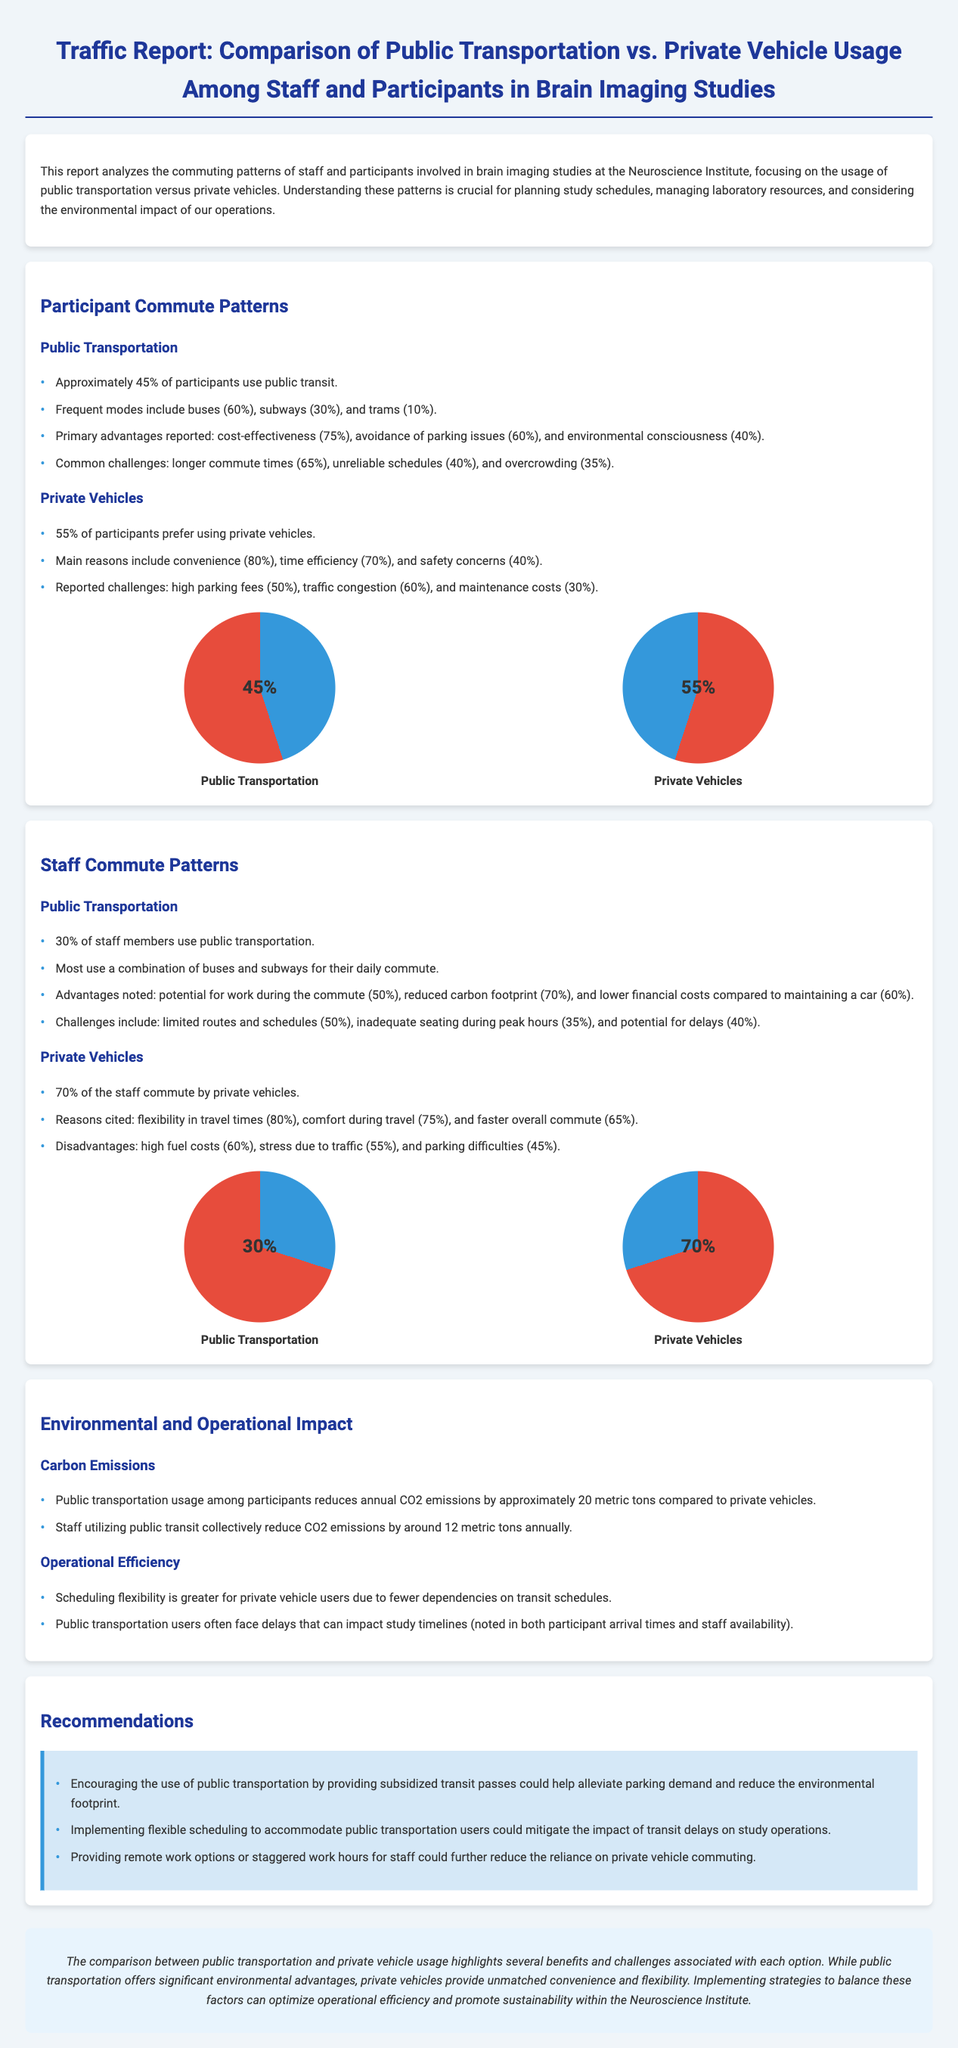what percentage of participants use public transportation? The document states that approximately 45% of participants use public transit.
Answer: 45% what are the main public transportation modes used by participants? The report lists buses (60%), subways (30%), and trams (10%) as the main modes.
Answer: buses, subways, trams what are the primary advantages of public transportation for participants? The advantages reported by participants include cost-effectiveness (75%), avoidance of parking issues (60%), and environmental consciousness (40%).
Answer: cost-effectiveness, avoidance of parking issues, environmental consciousness how much CO2 emissions are reduced annually by staff utilizing public transit? It is stated that staff utilizing public transit reduce CO2 emissions by around 12 metric tons annually.
Answer: 12 metric tons what flexibility benefit do private vehicle users have compared to public transport users? The document mentions that scheduling flexibility is greater for private vehicle users.
Answer: scheduling flexibility which group has a higher preference for private vehicles, participants or staff? The report shows that 70% of staff commute by private vehicles while 55% of participants prefer them.
Answer: staff what is a recommended strategy to encourage public transportation usage? The report recommends providing subsidized transit passes to encourage the use of public transportation.
Answer: subsidized transit passes what is a common challenge faced by public transportation users? One of the common challenges is longer commute times, noted by 65% of participants.
Answer: longer commute times what is the total percentage of staff using public transportation? The document specifies that 30% of staff members use public transportation.
Answer: 30% 